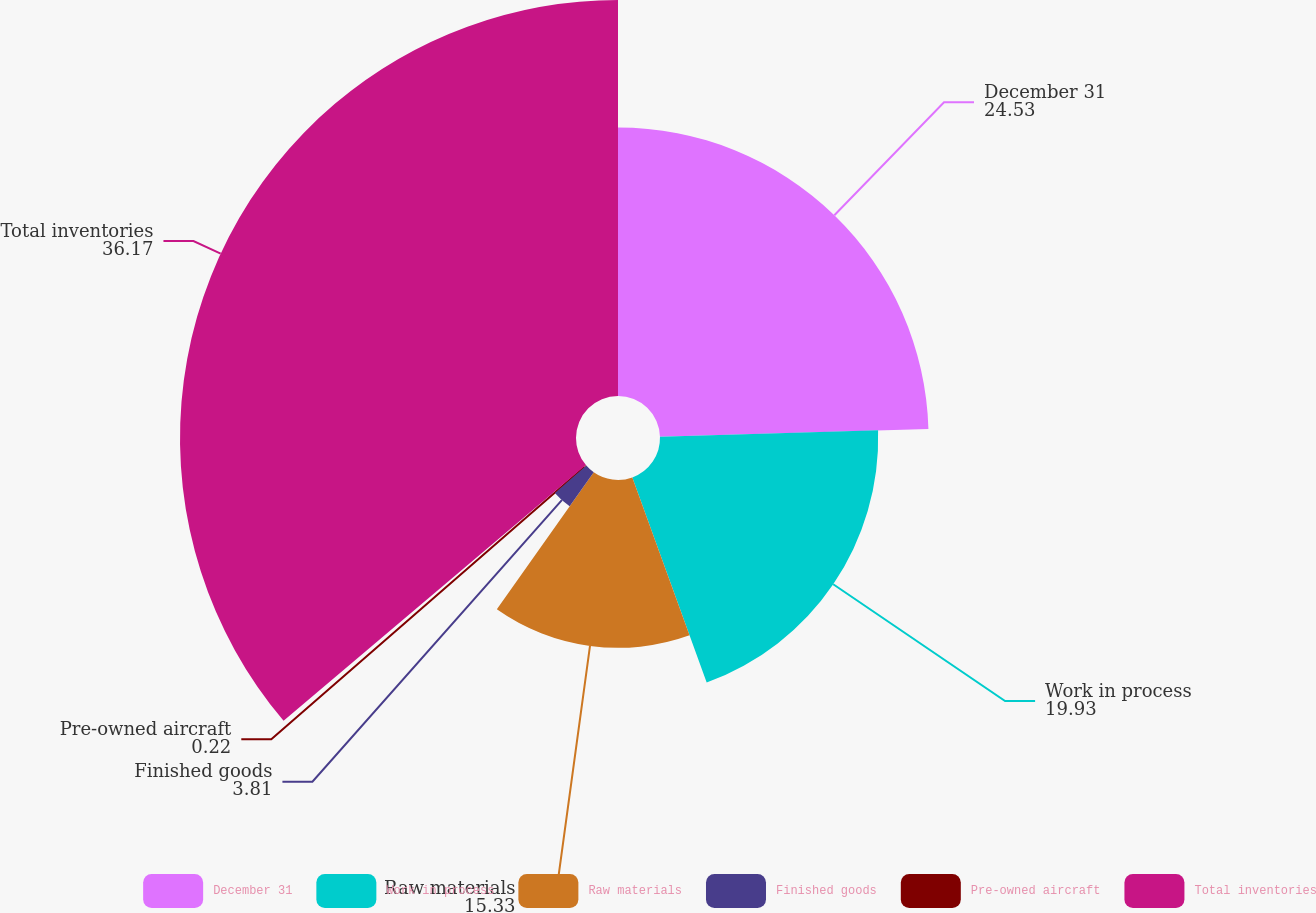<chart> <loc_0><loc_0><loc_500><loc_500><pie_chart><fcel>December 31<fcel>Work in process<fcel>Raw materials<fcel>Finished goods<fcel>Pre-owned aircraft<fcel>Total inventories<nl><fcel>24.53%<fcel>19.93%<fcel>15.33%<fcel>3.81%<fcel>0.22%<fcel>36.17%<nl></chart> 